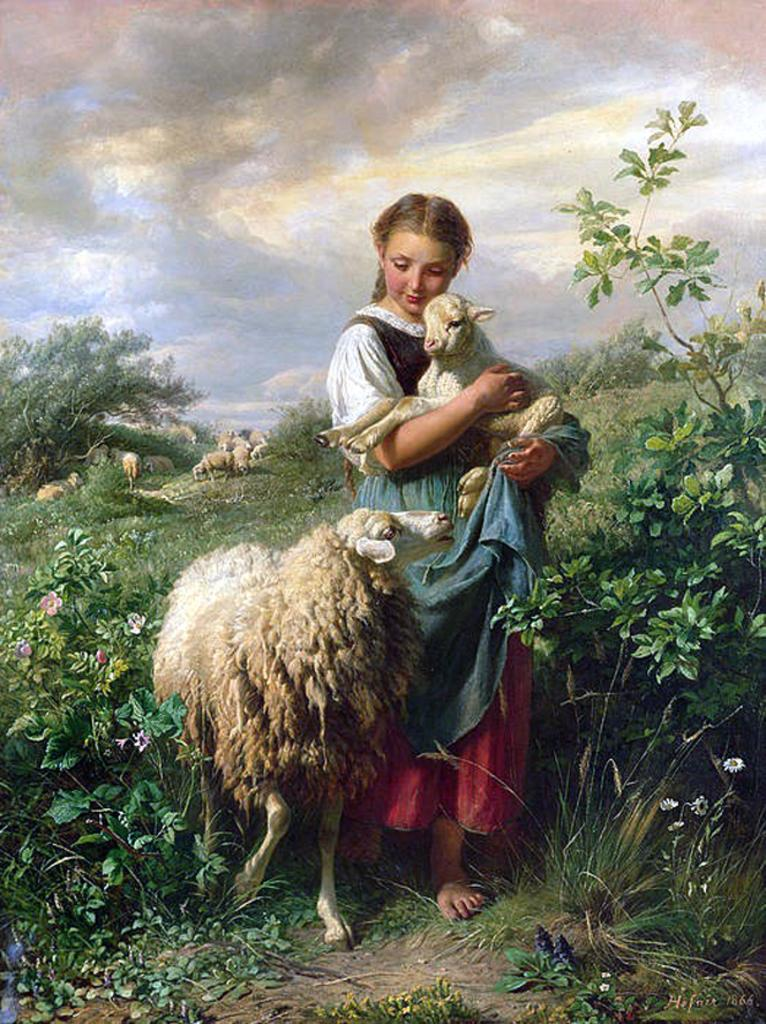What animal is the main subject of the painting? The painting features a sheep. What is the girl in the painting doing with the sheep? A girl is holding a lamb in the painting. What type of vegetation can be seen in the painting? There are plants depicted in the painting. What can be seen in the sky of the painting? The sky is visible in the painting, and clouds are present in it. How does the girl measure the range of the sheep in the painting? There is no indication in the painting that the girl is measuring the range of the sheep, nor is there any equipment or context to suggest such an activity. 